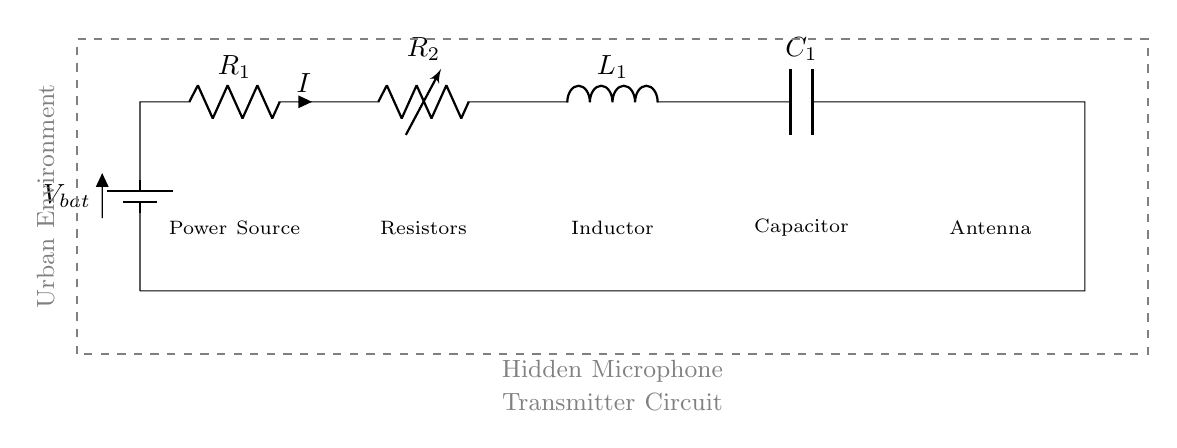What is the type of power source in this circuit? The circuit uses a battery, which is indicated by the symbol "battery1" in the diagram.
Answer: battery What is the value of the current flowing through resistor R1? The current through resistor R1 is denoted by "I" in the circuit, which represents the same current flowing through all the components since it's a series circuit.
Answer: I What component follows the resistor R2? In the series configuration, after resistor R2, the next component is an inductor, as shown by the symbol "L1" in the circuit series.
Answer: inductor What component is used to transmit the signal? The antenna (A1) at the end of the circuit is specifically designed for transmitting signals in this hidden microphone setup.
Answer: antenna How many energy-storing components are in this circuit? There are two energy-storing components: one inductor (L1) and one capacitor (C1), which together store energy in the form of magnetic and electric fields respectively.
Answer: two What is the main purpose of using a capacitor in this circuit? A capacitor is used to store and release electrical energy, helping to filter the signal and stabilize the circuit by providing a buffer against sudden changes in voltage.
Answer: stabilize What happens if the resistance R1 is increased? Increasing R1 will lower the overall current in the circuit according to Ohm's Law, as higher resistance results in less current flowing through a series circuit for a given voltage.
Answer: lower current 